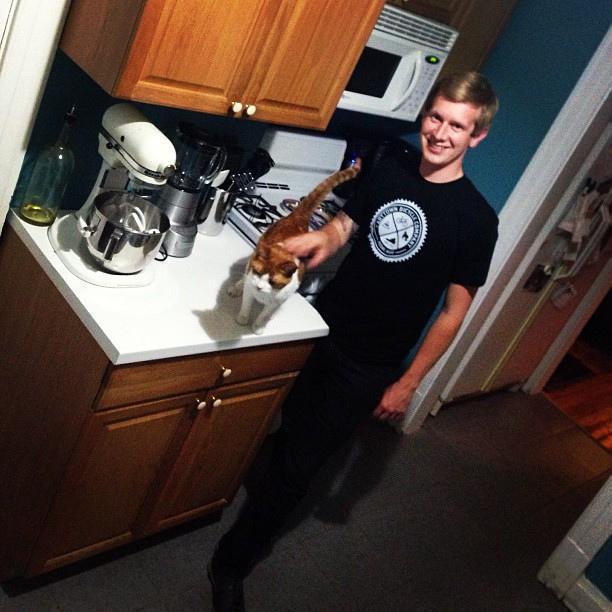How many kites do you see?
Give a very brief answer. 0. 